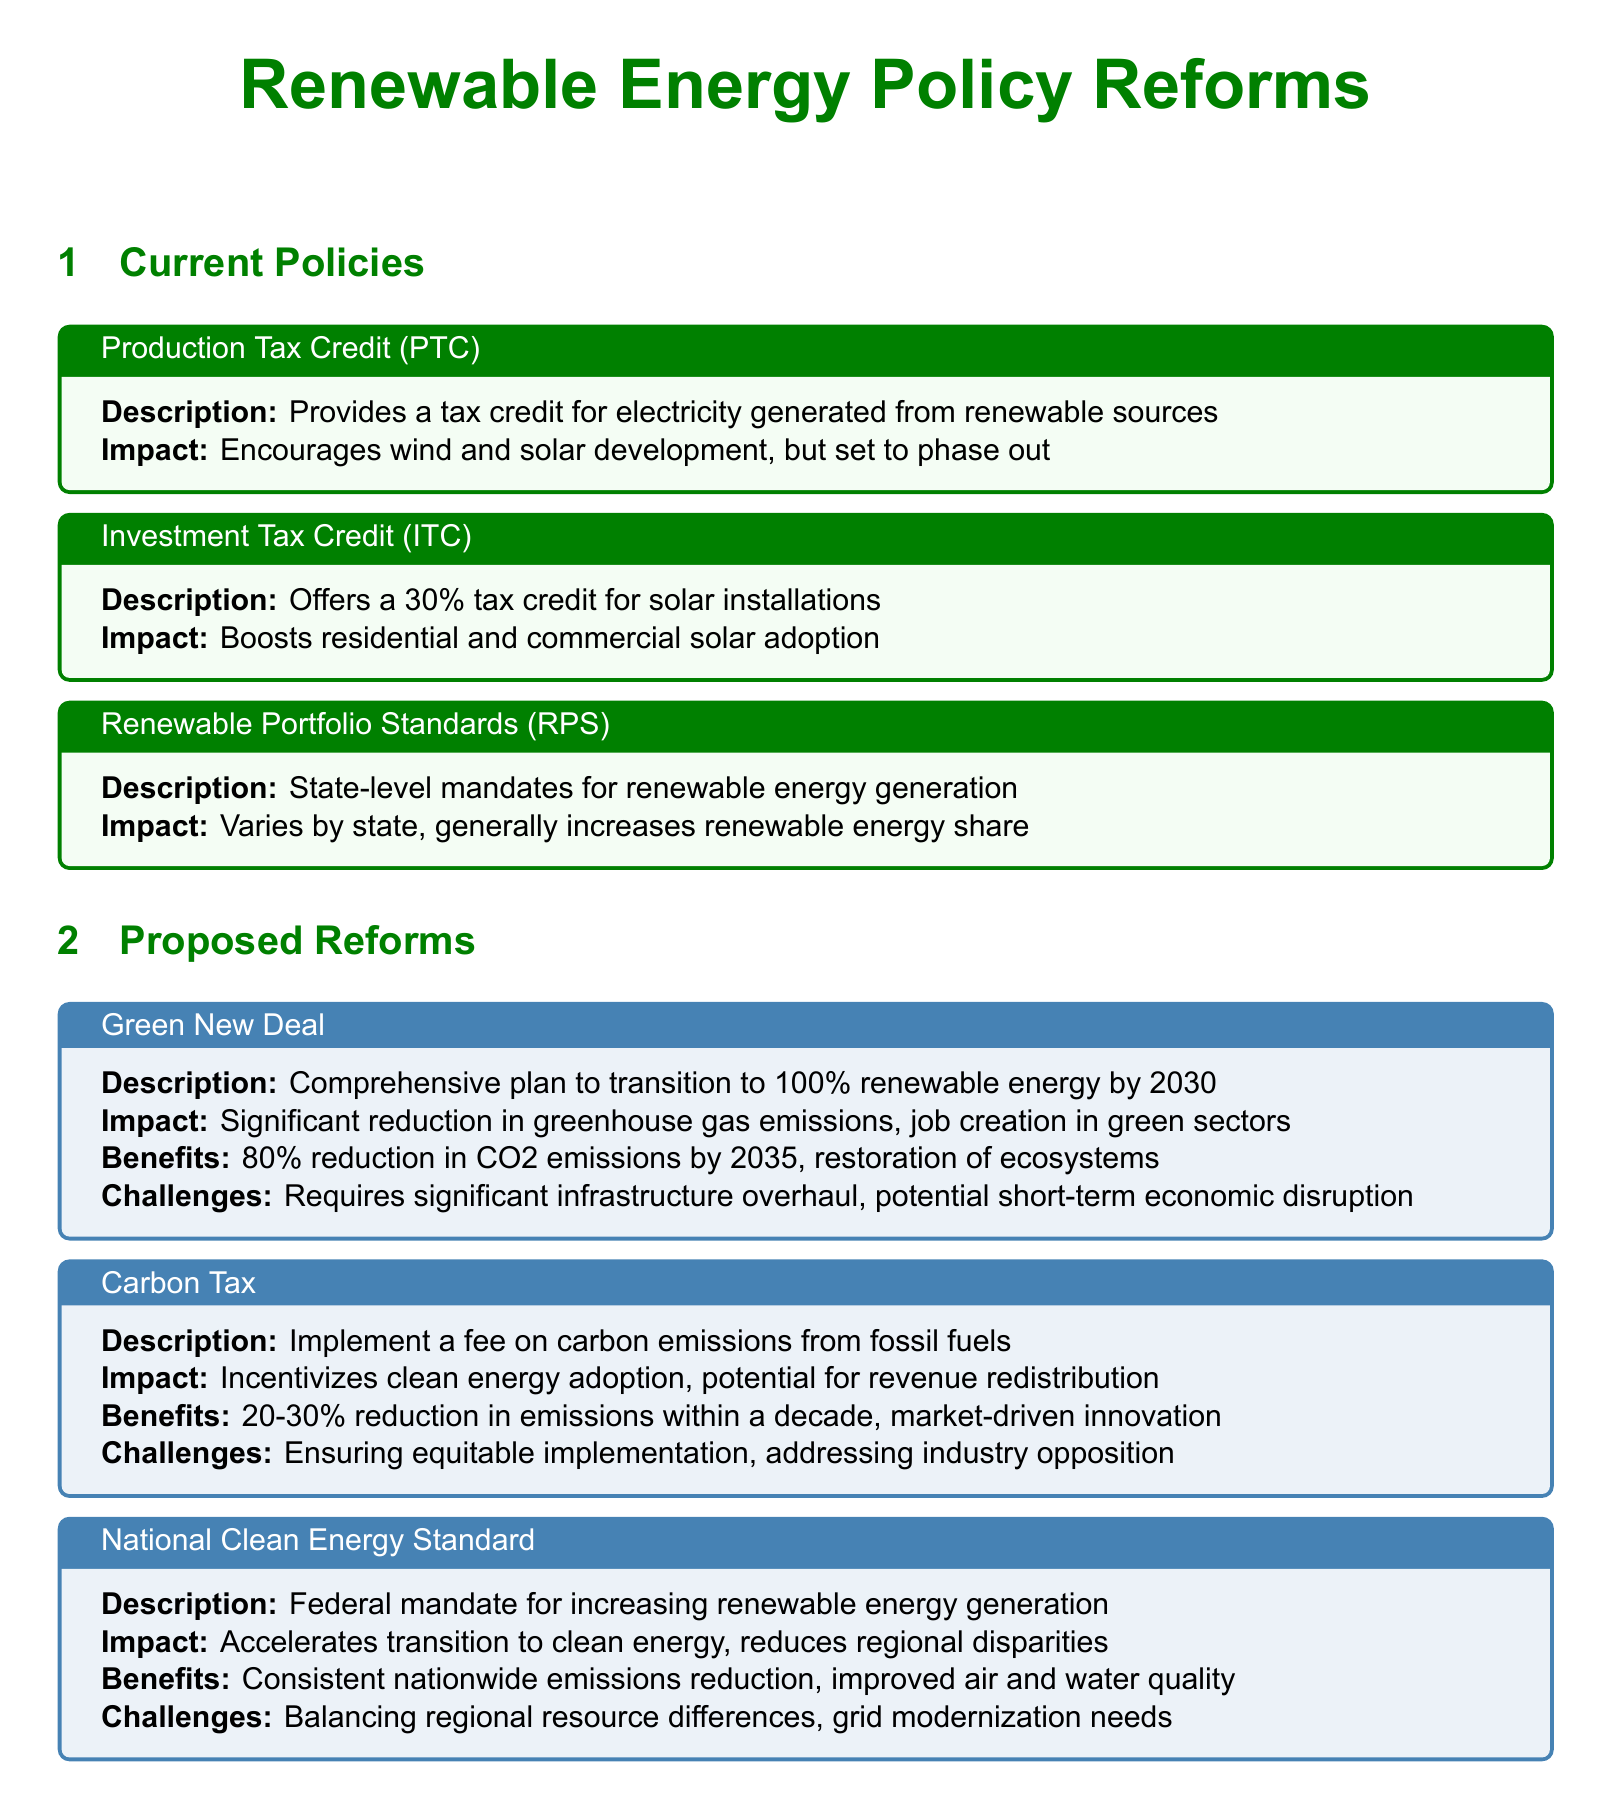What is the description of the Production Tax Credit? The description of the Production Tax Credit is that it provides a tax credit for electricity generated from renewable sources.
Answer: Provides a tax credit for electricity generated from renewable sources What is the impact of the Investment Tax Credit? The impact of the Investment Tax Credit is that it boosts residential and commercial solar adoption.
Answer: Boosts residential and commercial solar adoption What is the federal mandate proposed for increasing renewable energy generation? The federal mandate proposed for increasing renewable energy generation is the National Clean Energy Standard.
Answer: National Clean Energy Standard By what year does the Green New Deal aim for a transition to 100% renewable energy? The Green New Deal aims for a transition to 100% renewable energy by the year 2030.
Answer: 2030 What is one of the challenges of implementing a Carbon Tax? One of the challenges of implementing a Carbon Tax is ensuring equitable implementation.
Answer: Ensuring equitable implementation What is the expected reduction in CO2 emissions by 2035 with the Green New Deal? The expected reduction in CO2 emissions by 2035 with the Green New Deal is 80%.
Answer: 80% What is a benefit of the Carbon Tax? A benefit of the Carbon Tax is market-driven innovation.
Answer: Market-driven innovation What are Renewable Portfolio Standards primarily focused on? Renewable Portfolio Standards are primarily focused on state-level mandates for renewable energy generation.
Answer: State-level mandates for renewable energy generation 